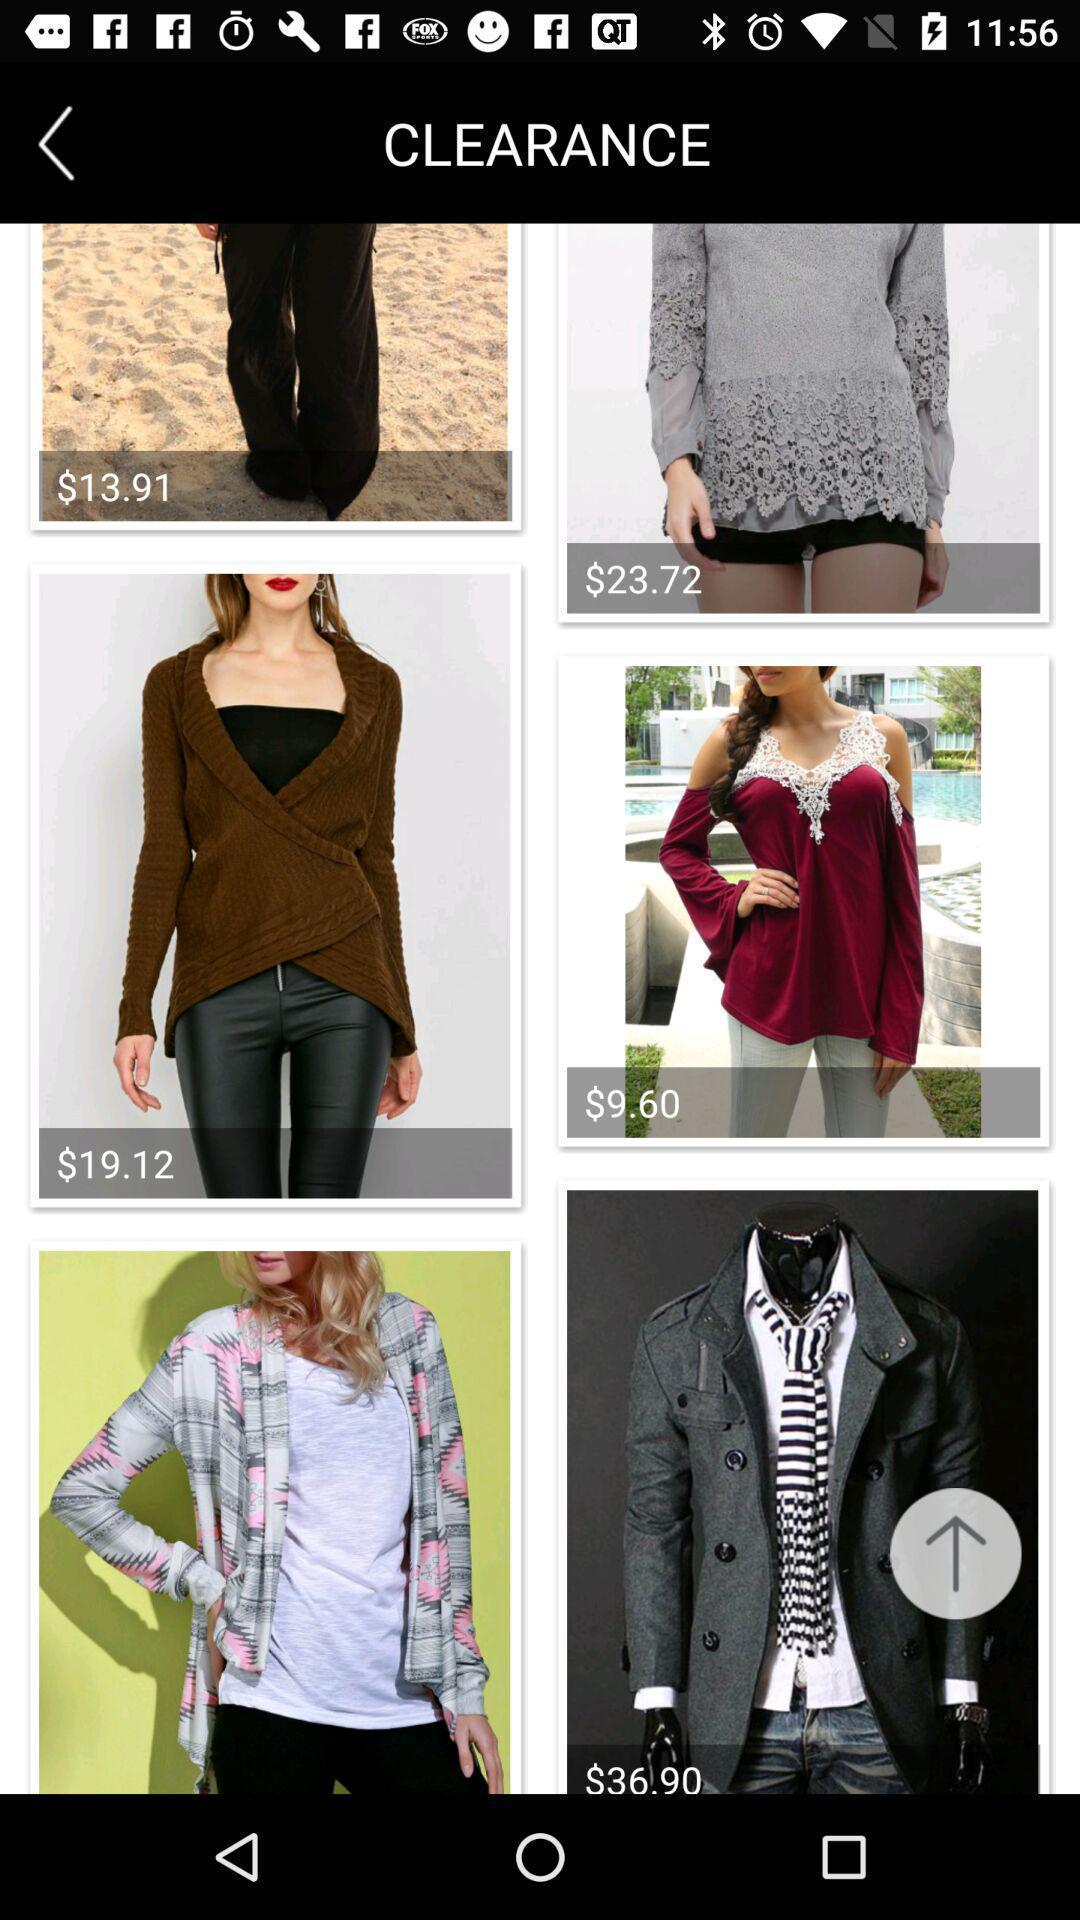Tell me about the visual elements in this screen capture. Screen page of a shopping app. 